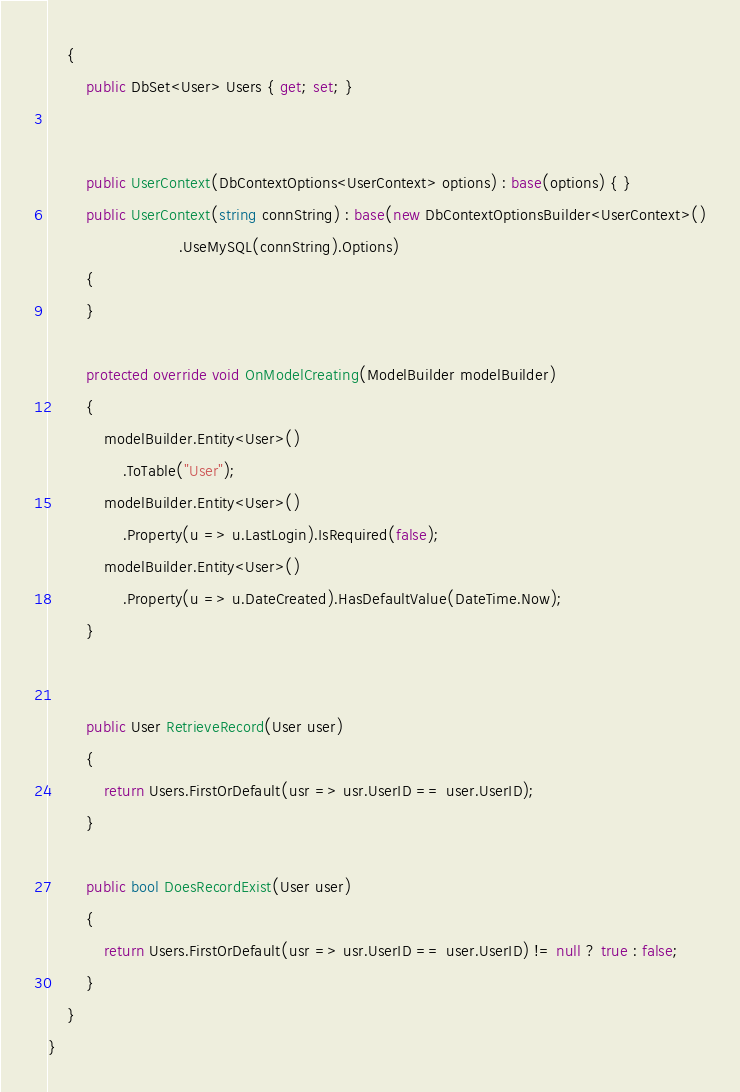Convert code to text. <code><loc_0><loc_0><loc_500><loc_500><_C#_>    {
        public DbSet<User> Users { get; set; }


        public UserContext(DbContextOptions<UserContext> options) : base(options) { }
        public UserContext(string connString) : base(new DbContextOptionsBuilder<UserContext>()
                            .UseMySQL(connString).Options)
        {
        }                        

        protected override void OnModelCreating(ModelBuilder modelBuilder)
        {
            modelBuilder.Entity<User>()
                .ToTable("User");
            modelBuilder.Entity<User>()
                .Property(u => u.LastLogin).IsRequired(false);
            modelBuilder.Entity<User>()
                .Property(u => u.DateCreated).HasDefaultValue(DateTime.Now);
        }

        
        public User RetrieveRecord(User user)
        {
            return Users.FirstOrDefault(usr => usr.UserID == user.UserID);
        }

        public bool DoesRecordExist(User user)
        {
            return Users.FirstOrDefault(usr => usr.UserID == user.UserID) != null ? true : false;
        }
    }
}  
</code> 